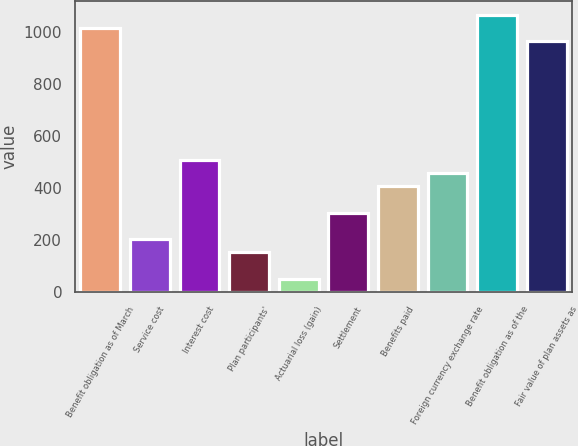Convert chart to OTSL. <chart><loc_0><loc_0><loc_500><loc_500><bar_chart><fcel>Benefit obligation as of March<fcel>Service cost<fcel>Interest cost<fcel>Plan participants'<fcel>Actuarial loss (gain)<fcel>Settlement<fcel>Benefits paid<fcel>Foreign currency exchange rate<fcel>Benefit obligation as of the<fcel>Fair value of plan assets as<nl><fcel>1015.3<fcel>203.14<fcel>507.7<fcel>152.38<fcel>50.86<fcel>304.66<fcel>406.18<fcel>456.94<fcel>1066.06<fcel>964.54<nl></chart> 